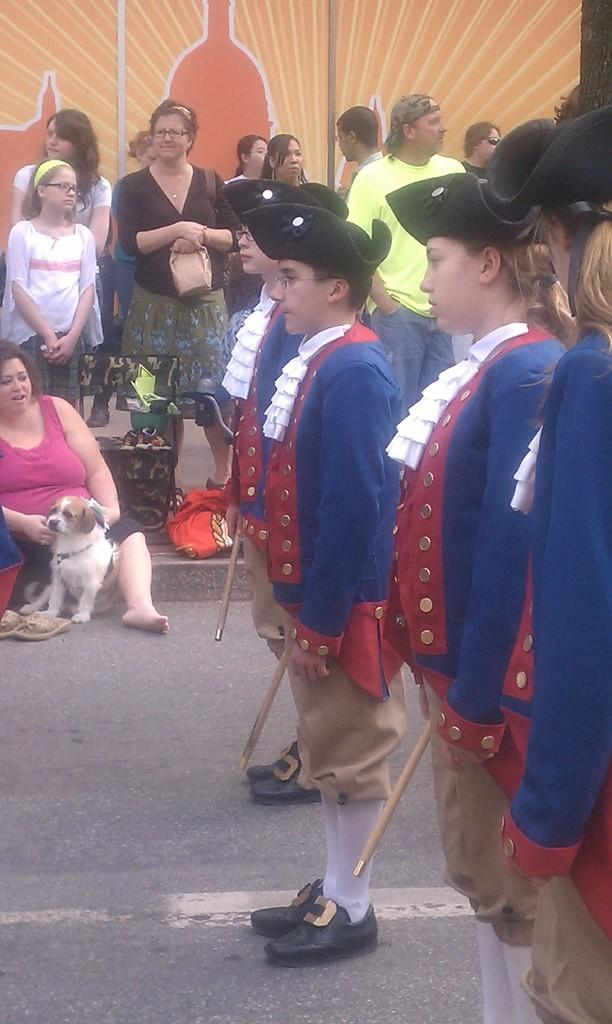What is the main subject of the image? The main subject of the image is a group of people. Can you describe the position of one of the individuals in the image? Yes, a woman is seated in the image. What is the woman holding in her hand? The woman is holding a dog in her hand. What type of chess piece is the woman holding in her hand? The woman is not holding a chess piece in her hand; she is holding a dog. What is the process for training the wrist in the image? There is no mention of wrist training or any process related to it in the image. 